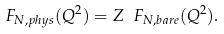Convert formula to latex. <formula><loc_0><loc_0><loc_500><loc_500>F _ { N , p h y s } ( Q ^ { 2 } ) = Z \ F _ { N , b a r e } ( Q ^ { 2 } ) .</formula> 